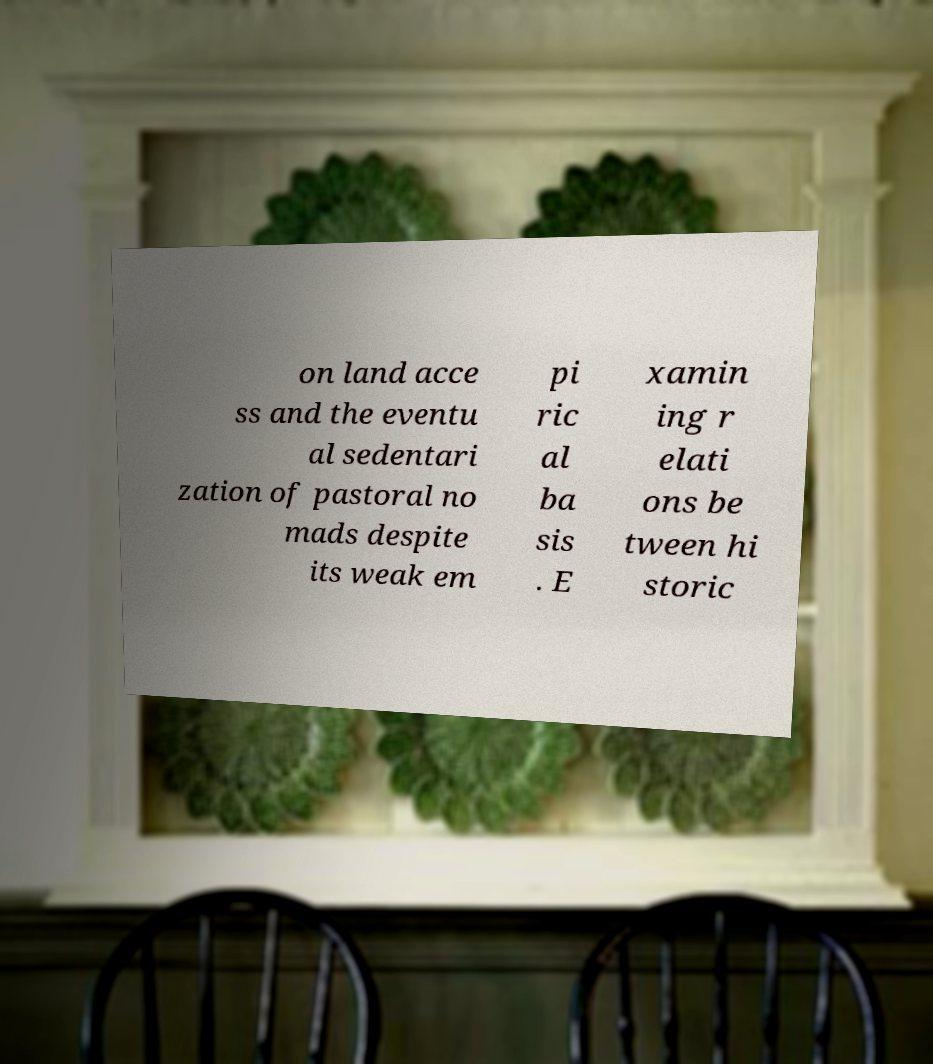Please identify and transcribe the text found in this image. on land acce ss and the eventu al sedentari zation of pastoral no mads despite its weak em pi ric al ba sis . E xamin ing r elati ons be tween hi storic 